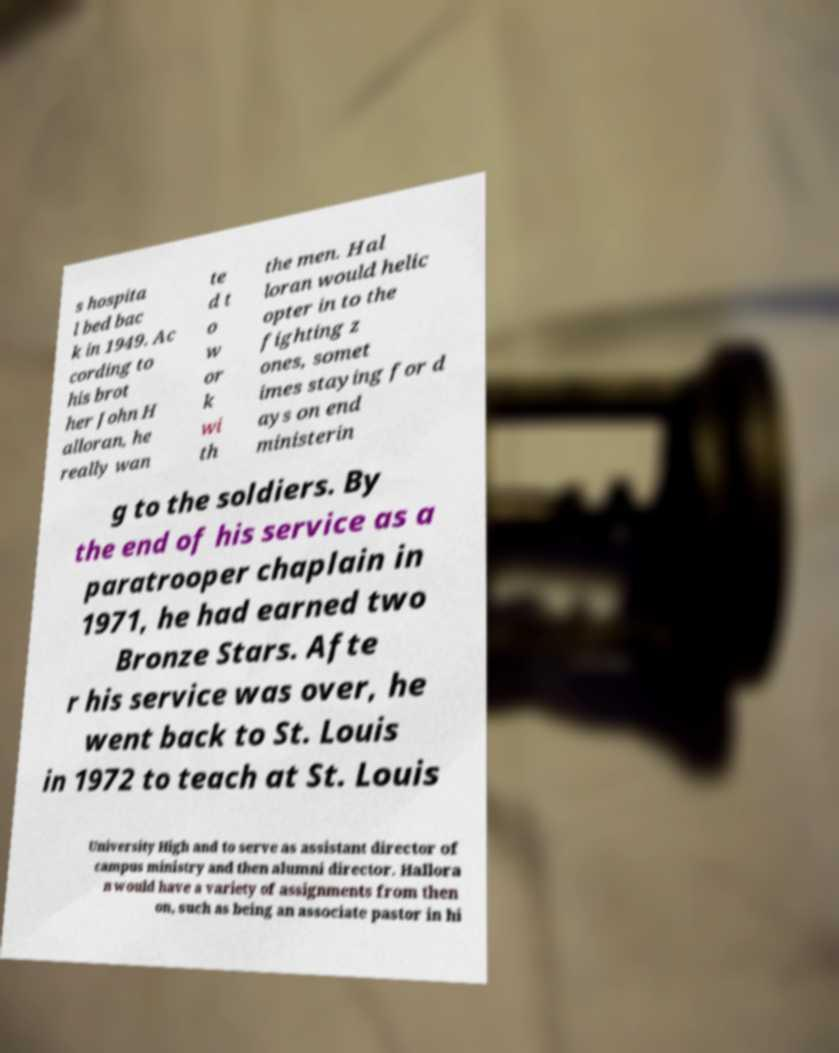Could you extract and type out the text from this image? s hospita l bed bac k in 1949. Ac cording to his brot her John H alloran, he really wan te d t o w or k wi th the men. Hal loran would helic opter in to the fighting z ones, somet imes staying for d ays on end ministerin g to the soldiers. By the end of his service as a paratrooper chaplain in 1971, he had earned two Bronze Stars. Afte r his service was over, he went back to St. Louis in 1972 to teach at St. Louis University High and to serve as assistant director of campus ministry and then alumni director. Hallora n would have a variety of assignments from then on, such as being an associate pastor in hi 